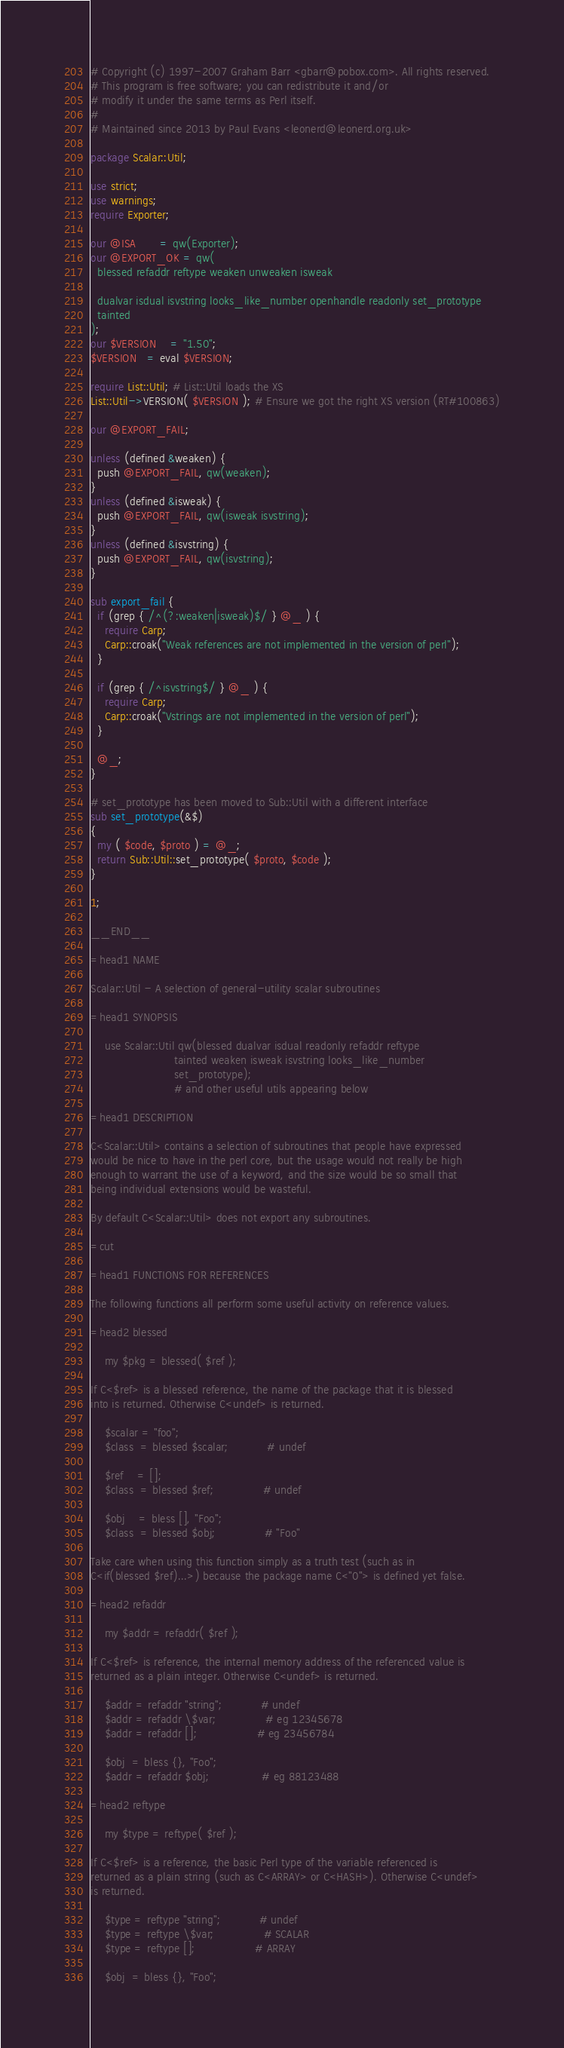<code> <loc_0><loc_0><loc_500><loc_500><_Perl_># Copyright (c) 1997-2007 Graham Barr <gbarr@pobox.com>. All rights reserved.
# This program is free software; you can redistribute it and/or
# modify it under the same terms as Perl itself.
#
# Maintained since 2013 by Paul Evans <leonerd@leonerd.org.uk>

package Scalar::Util;

use strict;
use warnings;
require Exporter;

our @ISA       = qw(Exporter);
our @EXPORT_OK = qw(
  blessed refaddr reftype weaken unweaken isweak

  dualvar isdual isvstring looks_like_number openhandle readonly set_prototype
  tainted
);
our $VERSION    = "1.50";
$VERSION   = eval $VERSION;

require List::Util; # List::Util loads the XS
List::Util->VERSION( $VERSION ); # Ensure we got the right XS version (RT#100863)

our @EXPORT_FAIL;

unless (defined &weaken) {
  push @EXPORT_FAIL, qw(weaken);
}
unless (defined &isweak) {
  push @EXPORT_FAIL, qw(isweak isvstring);
}
unless (defined &isvstring) {
  push @EXPORT_FAIL, qw(isvstring);
}

sub export_fail {
  if (grep { /^(?:weaken|isweak)$/ } @_ ) {
    require Carp;
    Carp::croak("Weak references are not implemented in the version of perl");
  }

  if (grep { /^isvstring$/ } @_ ) {
    require Carp;
    Carp::croak("Vstrings are not implemented in the version of perl");
  }

  @_;
}

# set_prototype has been moved to Sub::Util with a different interface
sub set_prototype(&$)
{
  my ( $code, $proto ) = @_;
  return Sub::Util::set_prototype( $proto, $code );
}

1;

__END__

=head1 NAME

Scalar::Util - A selection of general-utility scalar subroutines

=head1 SYNOPSIS

    use Scalar::Util qw(blessed dualvar isdual readonly refaddr reftype
                        tainted weaken isweak isvstring looks_like_number
                        set_prototype);
                        # and other useful utils appearing below

=head1 DESCRIPTION

C<Scalar::Util> contains a selection of subroutines that people have expressed
would be nice to have in the perl core, but the usage would not really be high
enough to warrant the use of a keyword, and the size would be so small that
being individual extensions would be wasteful.

By default C<Scalar::Util> does not export any subroutines.

=cut

=head1 FUNCTIONS FOR REFERENCES

The following functions all perform some useful activity on reference values.

=head2 blessed

    my $pkg = blessed( $ref );

If C<$ref> is a blessed reference, the name of the package that it is blessed
into is returned. Otherwise C<undef> is returned.

    $scalar = "foo";
    $class  = blessed $scalar;           # undef

    $ref    = [];
    $class  = blessed $ref;              # undef

    $obj    = bless [], "Foo";
    $class  = blessed $obj;              # "Foo"

Take care when using this function simply as a truth test (such as in
C<if(blessed $ref)...>) because the package name C<"0"> is defined yet false.

=head2 refaddr

    my $addr = refaddr( $ref );

If C<$ref> is reference, the internal memory address of the referenced value is
returned as a plain integer. Otherwise C<undef> is returned.

    $addr = refaddr "string";           # undef
    $addr = refaddr \$var;              # eg 12345678
    $addr = refaddr [];                 # eg 23456784

    $obj  = bless {}, "Foo";
    $addr = refaddr $obj;               # eg 88123488

=head2 reftype

    my $type = reftype( $ref );

If C<$ref> is a reference, the basic Perl type of the variable referenced is
returned as a plain string (such as C<ARRAY> or C<HASH>). Otherwise C<undef>
is returned.

    $type = reftype "string";           # undef
    $type = reftype \$var;              # SCALAR
    $type = reftype [];                 # ARRAY

    $obj  = bless {}, "Foo";</code> 